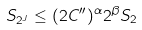Convert formula to latex. <formula><loc_0><loc_0><loc_500><loc_500>S _ { 2 ^ { J } } \leq ( 2 C ^ { \prime \prime } ) ^ { \alpha } 2 ^ { \beta } S _ { 2 }</formula> 